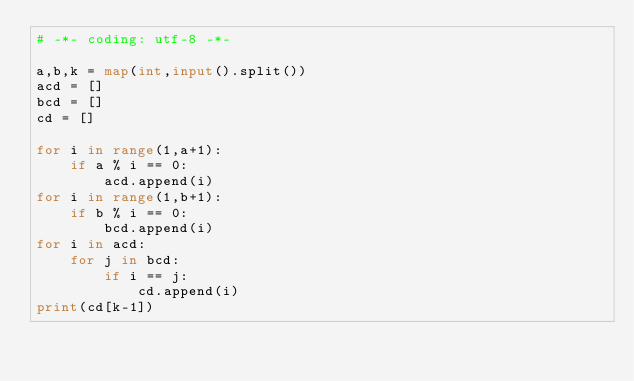<code> <loc_0><loc_0><loc_500><loc_500><_Python_># -*- coding: utf-8 -*-

a,b,k = map(int,input().split())
acd = []
bcd = []
cd = []

for i in range(1,a+1):
    if a % i == 0:
        acd.append(i)
for i in range(1,b+1):
    if b % i == 0:
        bcd.append(i)
for i in acd:
    for j in bcd:
        if i == j:
            cd.append(i)
print(cd[k-1])
</code> 